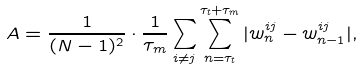Convert formula to latex. <formula><loc_0><loc_0><loc_500><loc_500>A = \frac { 1 } { ( N - 1 ) ^ { 2 } } \cdot \frac { 1 } { \tau _ { m } } \sum _ { i \ne j } \sum _ { n = \tau _ { t } } ^ { \tau _ { t } + \tau _ { m } } | w _ { n } ^ { i j } - w _ { n - 1 } ^ { i j } | ,</formula> 